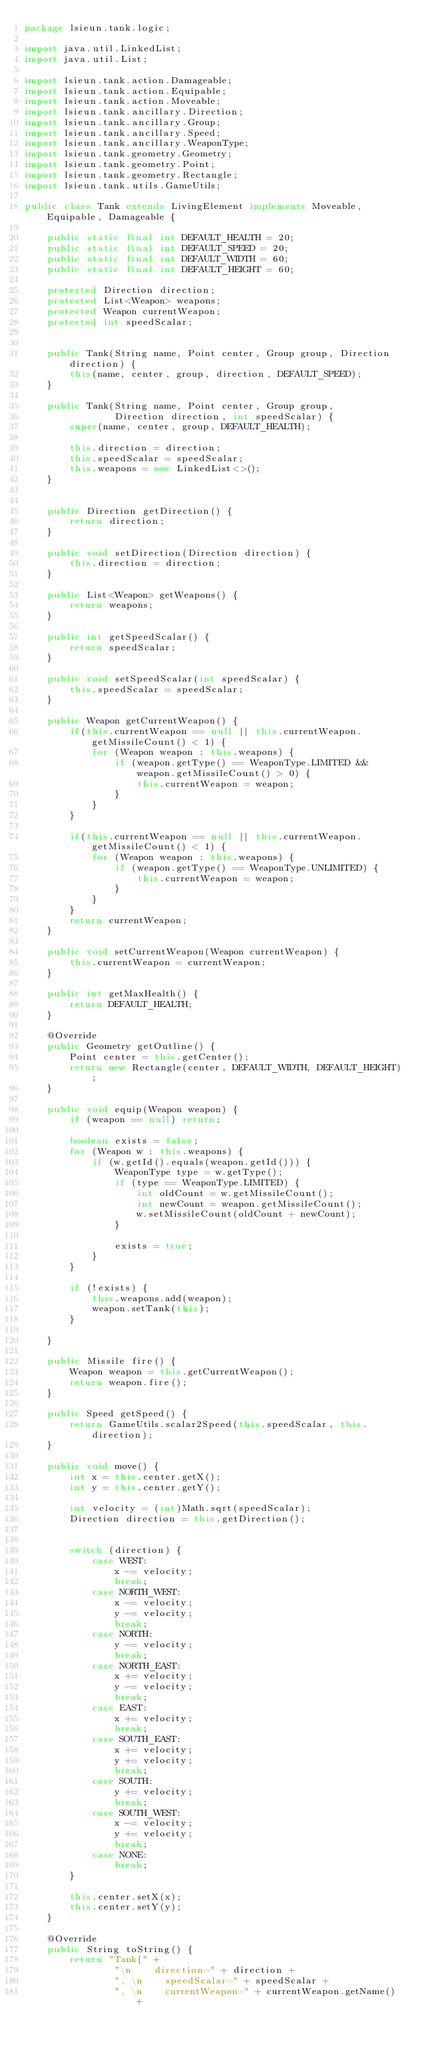Convert code to text. <code><loc_0><loc_0><loc_500><loc_500><_Java_>package lsieun.tank.logic;

import java.util.LinkedList;
import java.util.List;

import lsieun.tank.action.Damageable;
import lsieun.tank.action.Equipable;
import lsieun.tank.action.Moveable;
import lsieun.tank.ancillary.Direction;
import lsieun.tank.ancillary.Group;
import lsieun.tank.ancillary.Speed;
import lsieun.tank.ancillary.WeaponType;
import lsieun.tank.geometry.Geometry;
import lsieun.tank.geometry.Point;
import lsieun.tank.geometry.Rectangle;
import lsieun.tank.utils.GameUtils;

public class Tank extends LivingElement implements Moveable, Equipable, Damageable {

    public static final int DEFAULT_HEALTH = 20;
    public static final int DEFAULT_SPEED = 20;
    public static final int DEFAULT_WIDTH = 60;
    public static final int DEFAULT_HEIGHT = 60;

    protected Direction direction;
    protected List<Weapon> weapons;
    protected Weapon currentWeapon;
    protected int speedScalar;


    public Tank(String name, Point center, Group group, Direction direction) {
        this(name, center, group, direction, DEFAULT_SPEED);
    }

    public Tank(String name, Point center, Group group,
                Direction direction, int speedScalar) {
        super(name, center, group, DEFAULT_HEALTH);

        this.direction = direction;
        this.speedScalar = speedScalar;
        this.weapons = new LinkedList<>();
    }


    public Direction getDirection() {
        return direction;
    }

    public void setDirection(Direction direction) {
        this.direction = direction;
    }

    public List<Weapon> getWeapons() {
        return weapons;
    }

    public int getSpeedScalar() {
        return speedScalar;
    }

    public void setSpeedScalar(int speedScalar) {
        this.speedScalar = speedScalar;
    }

    public Weapon getCurrentWeapon() {
        if(this.currentWeapon == null || this.currentWeapon.getMissileCount() < 1) {
            for (Weapon weapon : this.weapons) {
                if (weapon.getType() == WeaponType.LIMITED && weapon.getMissileCount() > 0) {
                    this.currentWeapon = weapon;
                }
            }
        }

        if(this.currentWeapon == null || this.currentWeapon.getMissileCount() < 1) {
            for (Weapon weapon : this.weapons) {
                if (weapon.getType() == WeaponType.UNLIMITED) {
                    this.currentWeapon = weapon;
                }
            }
        }
        return currentWeapon;
    }

    public void setCurrentWeapon(Weapon currentWeapon) {
        this.currentWeapon = currentWeapon;
    }

    public int getMaxHealth() {
        return DEFAULT_HEALTH;
    }

    @Override
    public Geometry getOutline() {
        Point center = this.getCenter();
        return new Rectangle(center, DEFAULT_WIDTH, DEFAULT_HEIGHT);
    }

    public void equip(Weapon weapon) {
        if (weapon == null) return;

        boolean exists = false;
        for (Weapon w : this.weapons) {
            if (w.getId().equals(weapon.getId())) {
                WeaponType type = w.getType();
                if (type == WeaponType.LIMITED) {
                    int oldCount = w.getMissileCount();
                    int newCount = weapon.getMissileCount();
                    w.setMissileCount(oldCount + newCount);
                }

                exists = true;
            }
        }

        if (!exists) {
            this.weapons.add(weapon);
            weapon.setTank(this);
        }

    }

    public Missile fire() {
        Weapon weapon = this.getCurrentWeapon();
        return weapon.fire();
    }

    public Speed getSpeed() {
        return GameUtils.scalar2Speed(this.speedScalar, this.direction);
    }

    public void move() {
        int x = this.center.getX();
        int y = this.center.getY();

        int velocity = (int)Math.sqrt(speedScalar);
        Direction direction = this.getDirection();


        switch (direction) {
            case WEST:
                x -= velocity;
                break;
            case NORTH_WEST:
                x -= velocity;
                y -= velocity;
                break;
            case NORTH:
                y -= velocity;
                break;
            case NORTH_EAST:
                x += velocity;
                y -= velocity;
                break;
            case EAST:
                x += velocity;
                break;
            case SOUTH_EAST:
                x += velocity;
                y += velocity;
                break;
            case SOUTH:
                y += velocity;
                break;
            case SOUTH_WEST:
                x -= velocity;
                y += velocity;
                break;
            case NONE:
                break;
        }

        this.center.setX(x);
        this.center.setY(y);
    }

    @Override
    public String toString() {
        return "Tank{" +
                "\n    direction=" + direction +
                ", \n    speedScalar=" + speedScalar +
                ", \n    currentWeapon=" + currentWeapon.getName() +</code> 